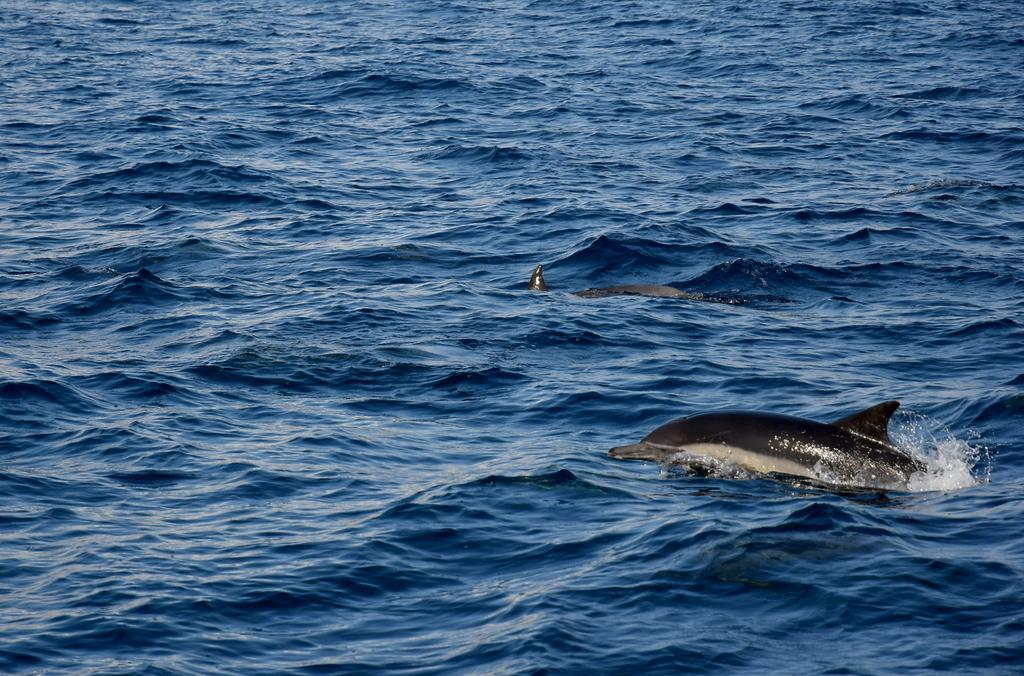What animals are present in the image? There are dolphins in the image. Where are the dolphins located? The dolphins are in the water. What type of flag is being waved by the dolphins in the image? There is no flag present in the image; it features dolphins in the water. What action are the dolphins performing on the pushcart in the image? There is no pushcart or action involving a pushcart in the image; it only features dolphins in the water. 